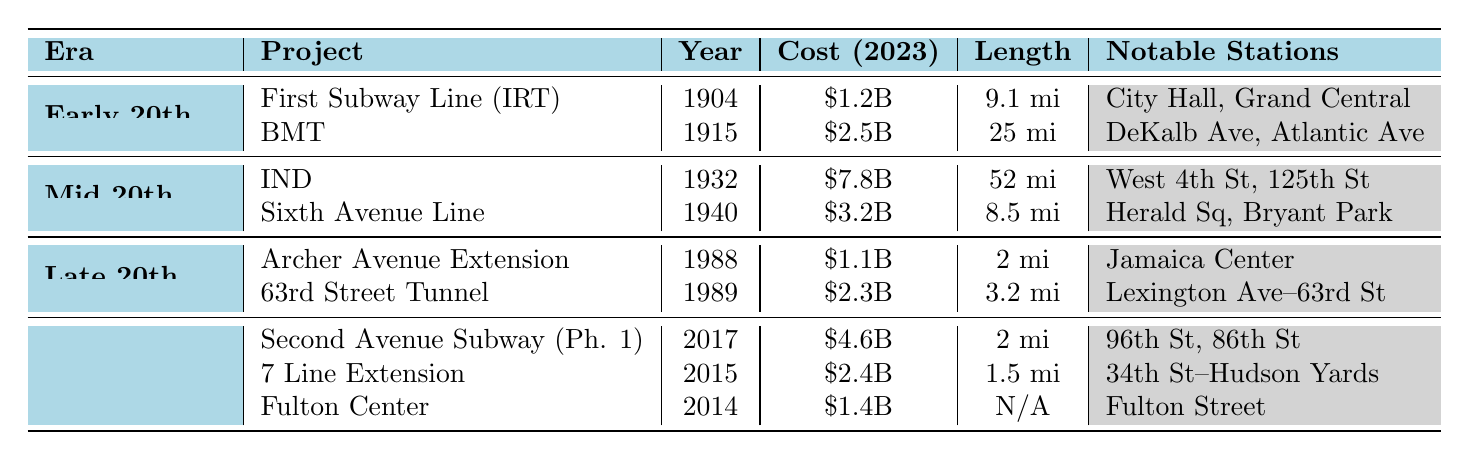What was the cost of the Independent Subway System? The cost of the Independent Subway System (IND) is listed in the table as $7.8 billion (adjusted to 2023).
Answer: $7.8 billion What year did the Second Avenue Subway (Phase 1) open? The table shows that the Second Avenue Subway (Phase 1) was completed in 2017.
Answer: 2017 How long is the Sixth Avenue Line? According to the table, the length of the Sixth Avenue Line is 8.5 miles.
Answer: 8.5 miles Which project had the longest length and what was that length? The Independent Subway System (IND) had the longest length at 52 miles, as indicated in the table.
Answer: 52 miles Is the cost of the 7 Line Extension greater than the cost of the Archer Avenue Extension? The cost of the 7 Line Extension is $2.4 billion and the cost of the Archer Avenue Extension is $1.1 billion. Since $2.4 billion is greater than $1.1 billion, the statement is true.
Answer: Yes What is the total cost of the subway expansion projects in the 21st Century? The costs for the 21st Century projects are $4.6 billion (Second Avenue Subway), $2.4 billion (7 Line Extension), and $1.4 billion (Fulton Center). Adding these gives $4.6 billion + $2.4 billion + $1.4 billion = $8.4 billion.
Answer: $8.4 billion Which era had the most expensive subway project, and what was the cost? The Mid 20th Century had the most expensive project, which was the Independent Subway System (IND) costing $7.8 billion.
Answer: Mid 20th Century, $7.8 billion How many notable stations are mentioned for the 63rd Street Tunnel? The table lists that the 63rd Street Tunnel has two notable stations: Lexington Avenue–63rd Street and Roosevelt Island.
Answer: 2 What is the average cost of the subway projects in the Late 20th Century? The costs for the Late 20th Century projects are $1.1 billion (Archer Avenue Extension) and $2.3 billion (63rd Street Tunnel). Adding them gives $1.1 billion + $2.3 billion = $3.4 billion, and dividing by the number of projects (2) gives $3.4 billion / 2 = $1.7 billion.
Answer: $1.7 billion In how many years were the five projects in the era of the 21st Century completed? The projects were completed in 2014 (Fulton Center), 2015 (7 Line Extension), and 2017 (Second Avenue Subway). From 2014 to 2017 is a total of 3 years.
Answer: 3 years 